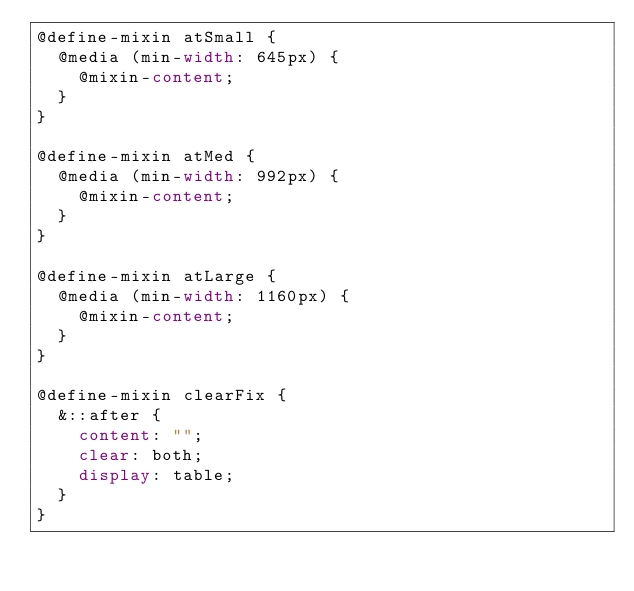<code> <loc_0><loc_0><loc_500><loc_500><_CSS_>@define-mixin atSmall {
  @media (min-width: 645px) {
    @mixin-content;
  }
}

@define-mixin atMed {
  @media (min-width: 992px) {
    @mixin-content;
  }
}

@define-mixin atLarge {
  @media (min-width: 1160px) {
    @mixin-content;
  }
}

@define-mixin clearFix {
  &::after {
    content: "";
    clear: both;
    display: table;
  }
}</code> 